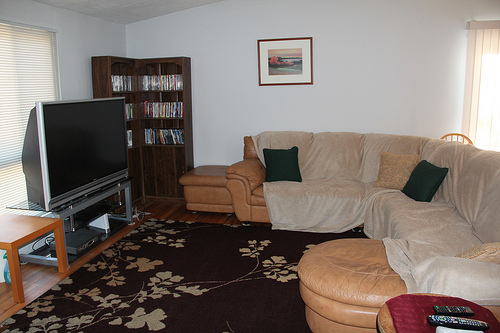Please provide a short description for this region: [0.36, 0.48, 0.48, 0.6]. This part of the room features a footrest, conveniently placed beside the sofa, providing comfort and utility. 